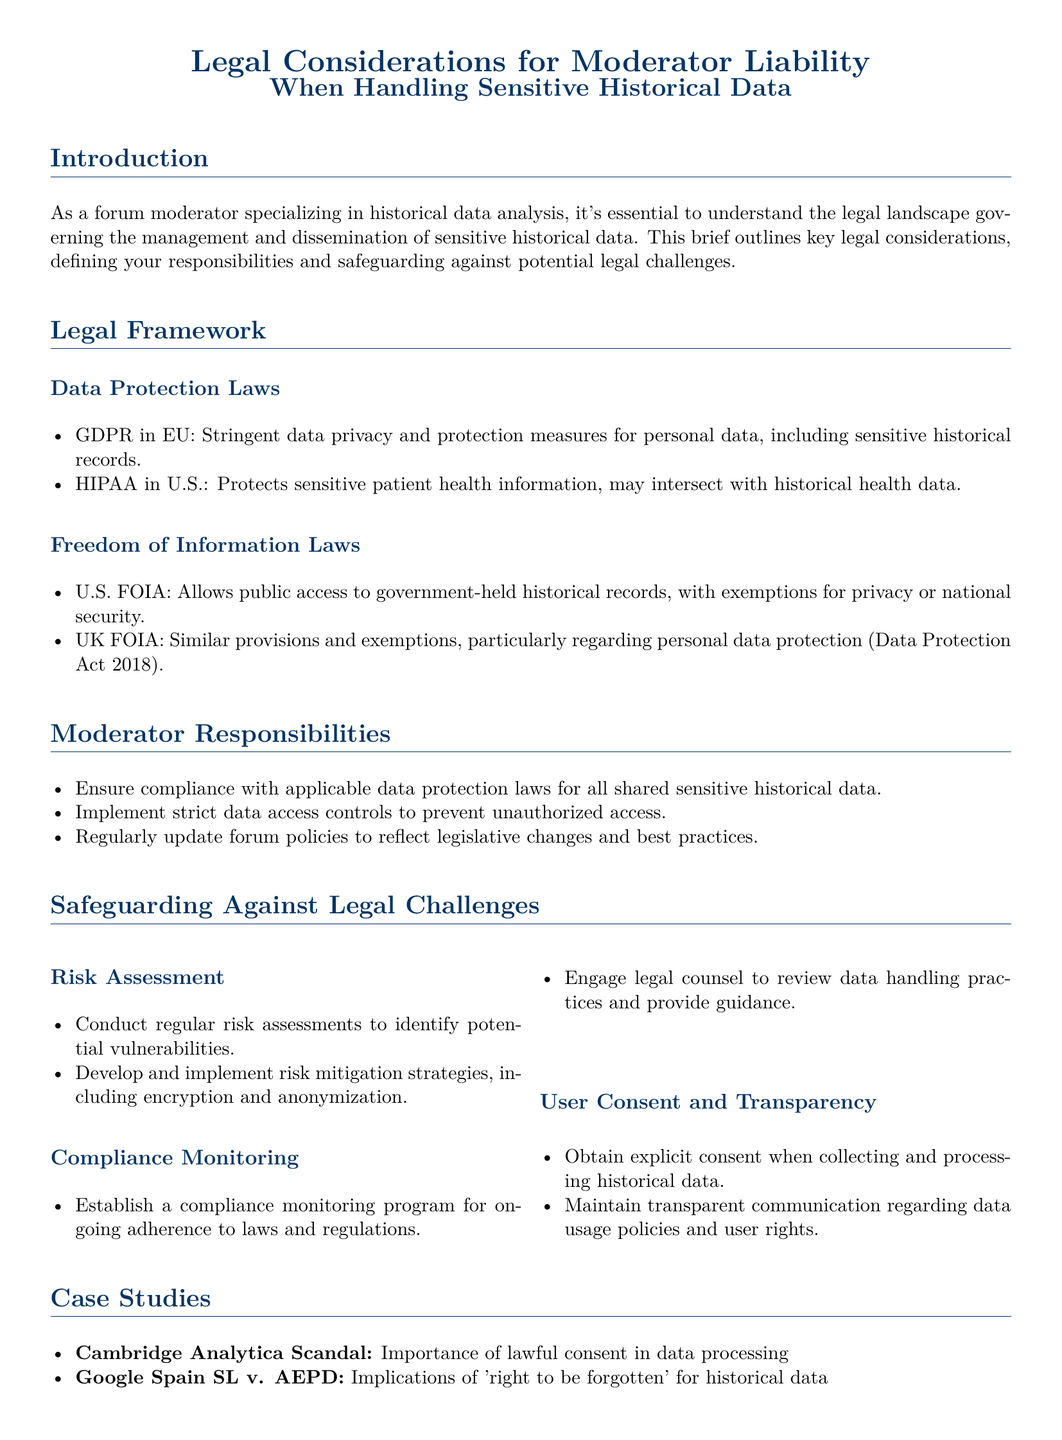What are the data protection laws mentioned? The brief mentions GDPR in the EU and HIPAA in the U.S. as key data protection laws.
Answer: GDPR, HIPAA What does FOIA stand for? The document states that FOIA refers to the Freedom of Information Act.
Answer: Freedom of Information Act What is a key responsibility of forum moderators regarding sensitive historical data? The brief outlines that one responsibility is to ensure compliance with applicable data protection laws.
Answer: Compliance with data protection laws What type of user consent is required when handling historical data? The document specifies that explicit consent should be obtained when collecting and processing historical data.
Answer: Explicit consent What case illustrates the importance of lawful consent in data processing? The case study listed under the case studies section highlights the Cambridge Analytica scandal.
Answer: Cambridge Analytica Scandal How many sections are in the brief? The document is divided into several sections, focusing on various legal considerations and moderator responsibilities.
Answer: Six sections What is one method suggested for safeguarding against legal challenges? The brief suggests conducting regular risk assessments as a part of safeguarding measures.
Answer: Risk assessments Who should be engaged for guidance on data handling practices? The document recommends engaging legal counsel for guidance on compliance and data handling.
Answer: Legal counsel 